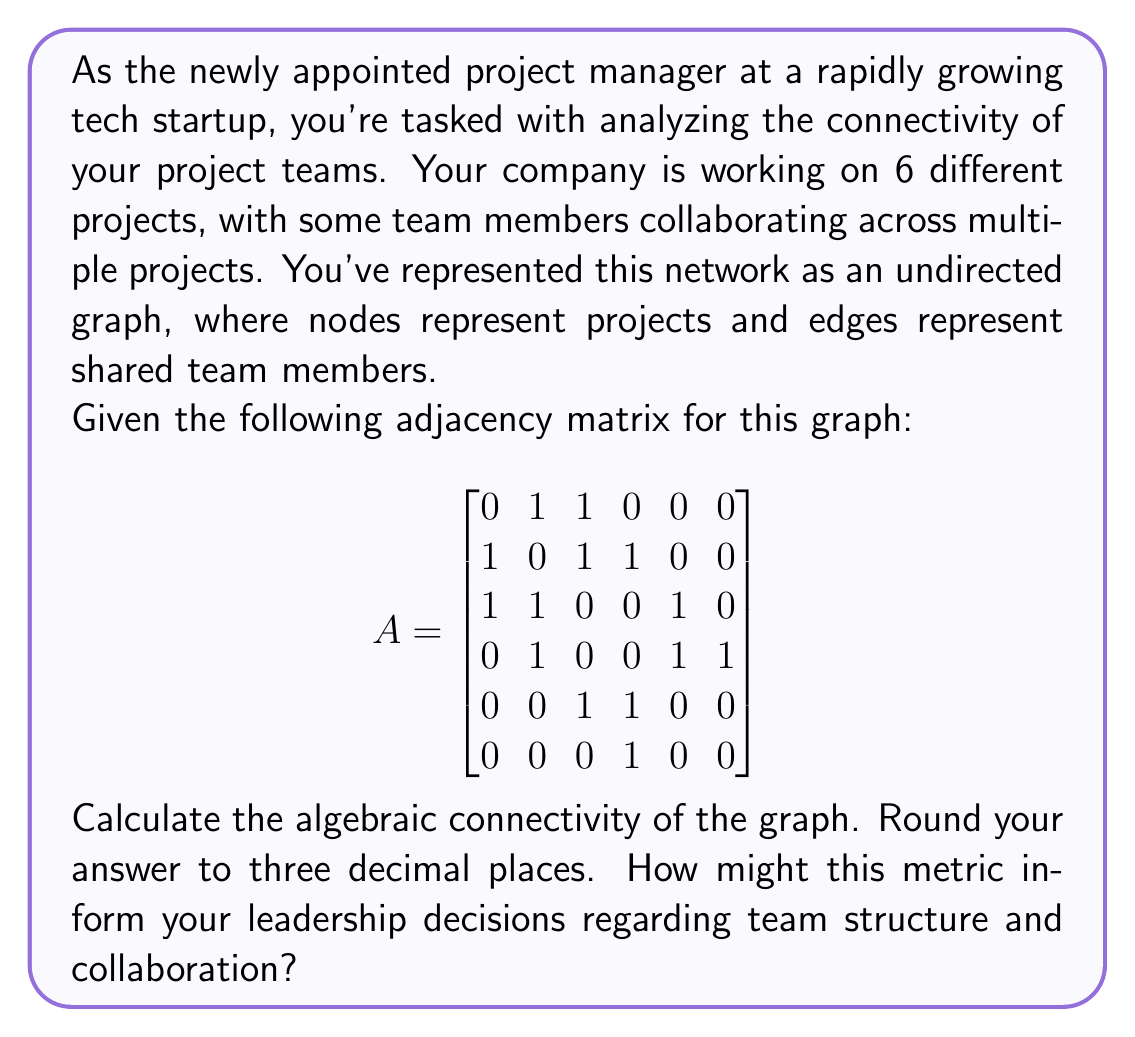Give your solution to this math problem. To solve this problem, we'll follow these steps:

1) The algebraic connectivity of a graph is defined as the second smallest eigenvalue of the Laplacian matrix of the graph.

2) First, we need to calculate the Laplacian matrix $L$. The Laplacian matrix is defined as $L = D - A$, where $D$ is the degree matrix and $A$ is the adjacency matrix.

3) To find the degree matrix $D$, we sum each row of the adjacency matrix:

   $$D = \begin{bmatrix}
   2 & 0 & 0 & 0 & 0 & 0 \\
   0 & 3 & 0 & 0 & 0 & 0 \\
   0 & 0 & 3 & 0 & 0 & 0 \\
   0 & 0 & 0 & 3 & 0 & 0 \\
   0 & 0 & 0 & 0 & 2 & 0 \\
   0 & 0 & 0 & 0 & 0 & 1
   \end{bmatrix}$$

4) Now we can calculate the Laplacian matrix $L = D - A$:

   $$L = \begin{bmatrix}
   2 & -1 & -1 & 0 & 0 & 0 \\
   -1 & 3 & -1 & -1 & 0 & 0 \\
   -1 & -1 & 3 & 0 & -1 & 0 \\
   0 & -1 & 0 & 3 & -1 & -1 \\
   0 & 0 & -1 & -1 & 2 & 0 \\
   0 & 0 & 0 & -1 & 0 & 1
   \end{bmatrix}$$

5) We need to find the eigenvalues of this matrix. Using a computer algebra system or numerical methods, we can calculate the eigenvalues:

   $\lambda_1 \approx 0$
   $\lambda_2 \approx 0.5188$
   $\lambda_3 \approx 1.2087$
   $\lambda_4 \approx 2.0000$
   $\lambda_5 \approx 3.2725$
   $\lambda_6 \approx 4.0000$

6) The algebraic connectivity is the second smallest eigenvalue, which is $\lambda_2 \approx 0.5188$.

7) Rounding to three decimal places, we get 0.519.

The algebraic connectivity provides insight into the overall connectivity and robustness of the network. A higher value indicates a more connected and robust network, while a lower value suggests a network that's more easily disconnected.

In this case, the value of 0.519 is relatively low, indicating that the project network is not very well connected. This could inform leadership decisions by suggesting:

1) The need for more cross-project collaboration to increase network robustness.
2) Potential risks in information flow or resource sharing between projects.
3) Opportunities to strategically assign team members to bridge gaps between less connected projects.
4) The possibility of restructuring teams or project assignments to improve overall connectivity.

By addressing these issues, a leader could improve team efficiency, knowledge sharing, and overall project resilience.
Answer: 0.519 